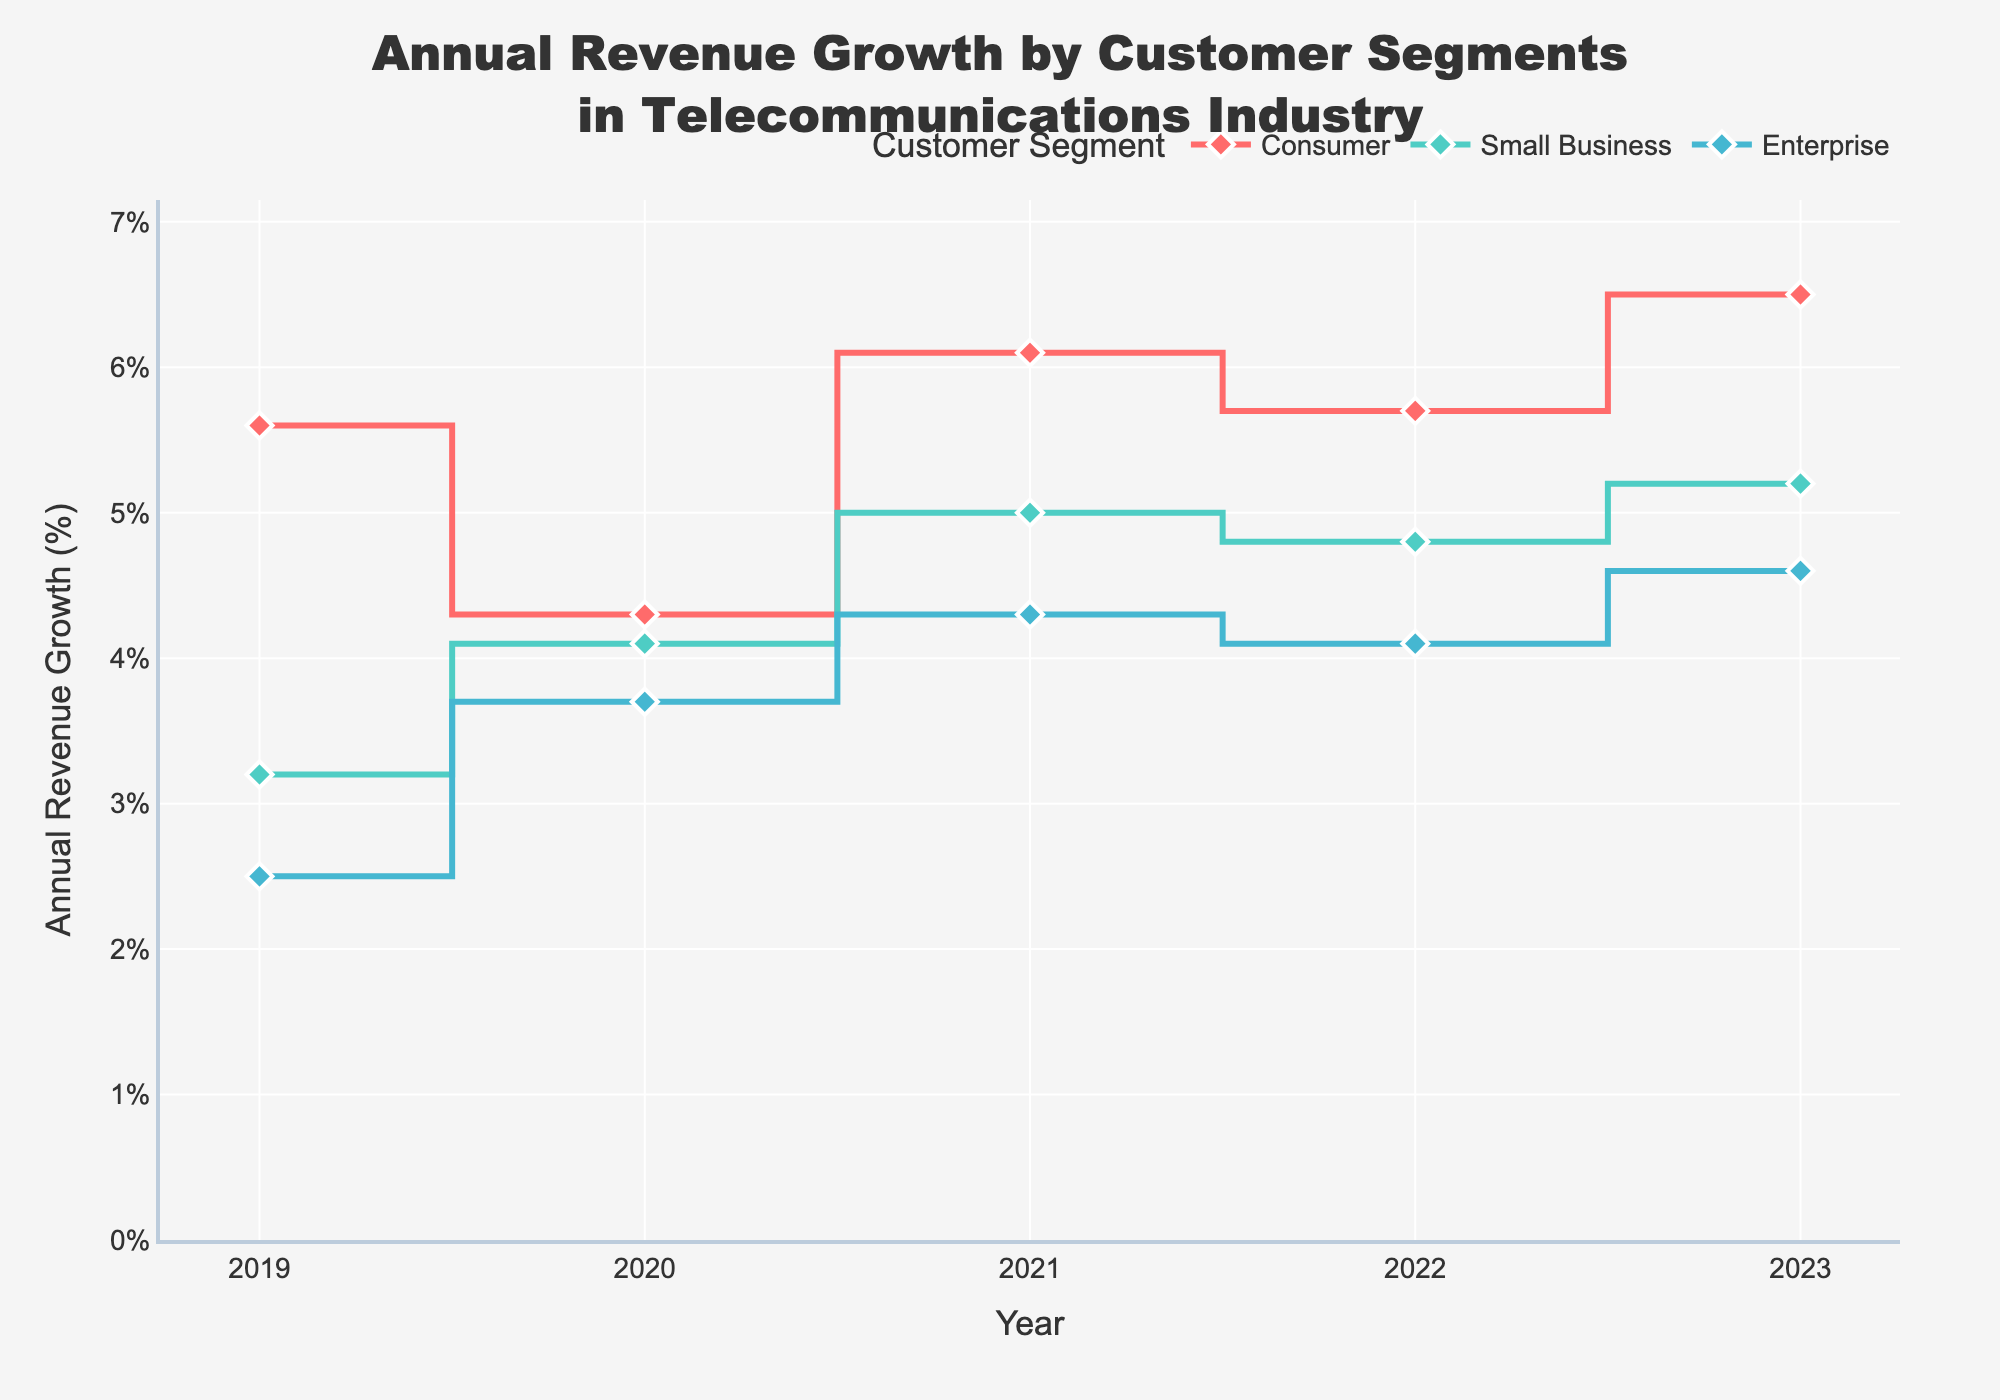What is the title of the figure? The title is usually found at the top of the figure. In this case, it reads 'Annual Revenue Growth by Customer Segments in Telecommunications Industry'.
Answer: Annual Revenue Growth by Customer Segments in Telecommunications Industry Which customer segment had the highest annual revenue growth in 2023? To identify the segment with the highest growth in 2023, look at the y-values for each segment at the year 2023. The Consumer segment has the highest value at 6.5%.
Answer: Consumer What is the trend of the annual revenue growth for the Consumer segment from 2019 to 2023? Observing the Consumer segment line, the growth percentages for the years 2019 to 2023 are 5.6, 4.3, 6.1, 5.7, and 6.5 respectively. This shows overall growth with some fluctuations.
Answer: Increasing with fluctuations Which year showed the highest annual revenue growth for the Enterprise segment? We track the growth percentages for the Enterprise segment across all years: 2019 (2.5%), 2020 (3.7%), 2021 (4.3%), 2022 (4.1%), 2023 (4.6%). The highest is in 2021 at 4.3%.
Answer: 2021 What is the difference in annual revenue growth between the Small Business and Enterprise segments in 2023? Looking at the 2023 values, Small Business has 5.2% and Enterprise has 4.6%. The difference is 5.2 - 4.6 = 0.6%.
Answer: 0.6% How many customer segments are shown in the figure? To find the number of segments, observe the legend or count distinct lines. There are three: Consumer, Small Business, and Enterprise.
Answer: 3 Which customer segment exhibited the most stable growth from 2019 to 2023? Stability can be judged by the least fluctuation in growth percentages. The Small Business segment ranged from 3.2% to 5.2%, showing comparatively steady growth.
Answer: Small Business What was the average annual revenue growth for the Consumer segment over the 5 years? Calculate the average of the values for the Consumer segment: (5.6 + 4.3 + 6.1 + 5.7 + 6.5)/5 = 5.64%.
Answer: 5.64% Did any customer segment's annual revenue growth decline between any consecutive years? If so, which segment and between which years? The Enterprise segment shows a decline from 2021 (4.3%) to 2022 (4.1%). The Consumer segment declines from 2019 (5.6%) to 2020 (4.3%).
Answer: Consumer (2019-2020), Enterprise (2021-2022) Which customer segment has the most pronounced increase in growth in any one year, and what is the increase? By comparing the year-over-year changes for all segments, the Consumer segment from 2022 to 2023 increases from 5.7% to 6.5%, an increase of 0.8%, which is the most pronounced.
Answer: Consumer, 0.8% 